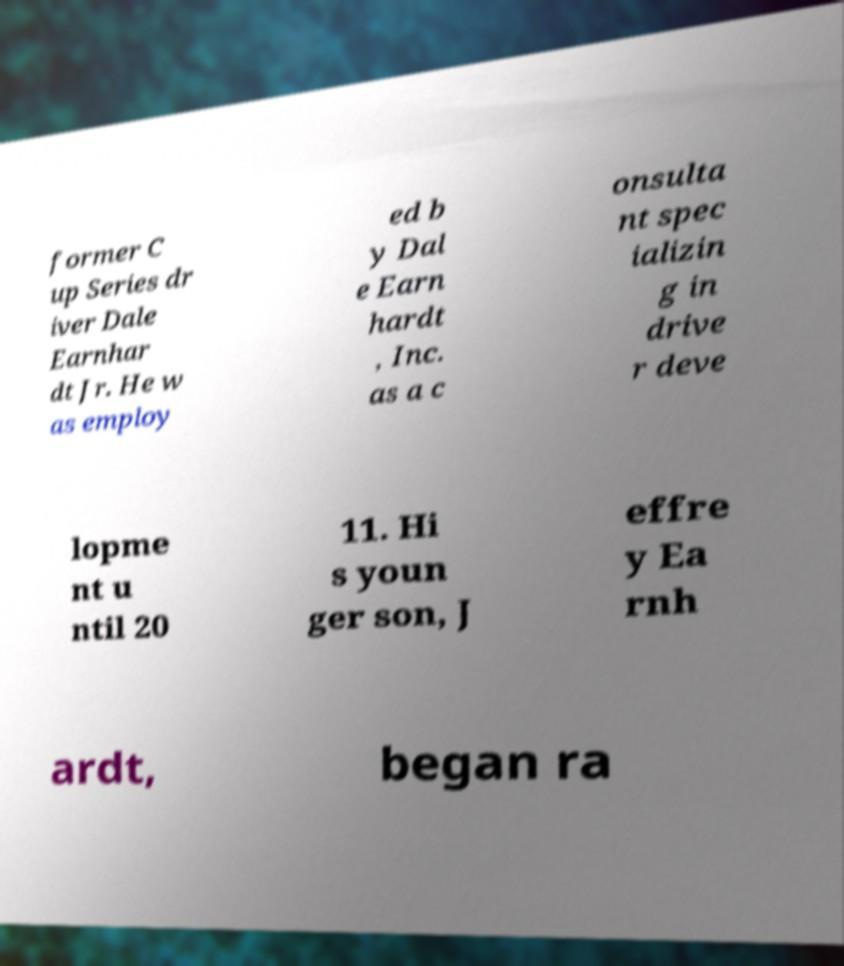Can you accurately transcribe the text from the provided image for me? former C up Series dr iver Dale Earnhar dt Jr. He w as employ ed b y Dal e Earn hardt , Inc. as a c onsulta nt spec ializin g in drive r deve lopme nt u ntil 20 11. Hi s youn ger son, J effre y Ea rnh ardt, began ra 